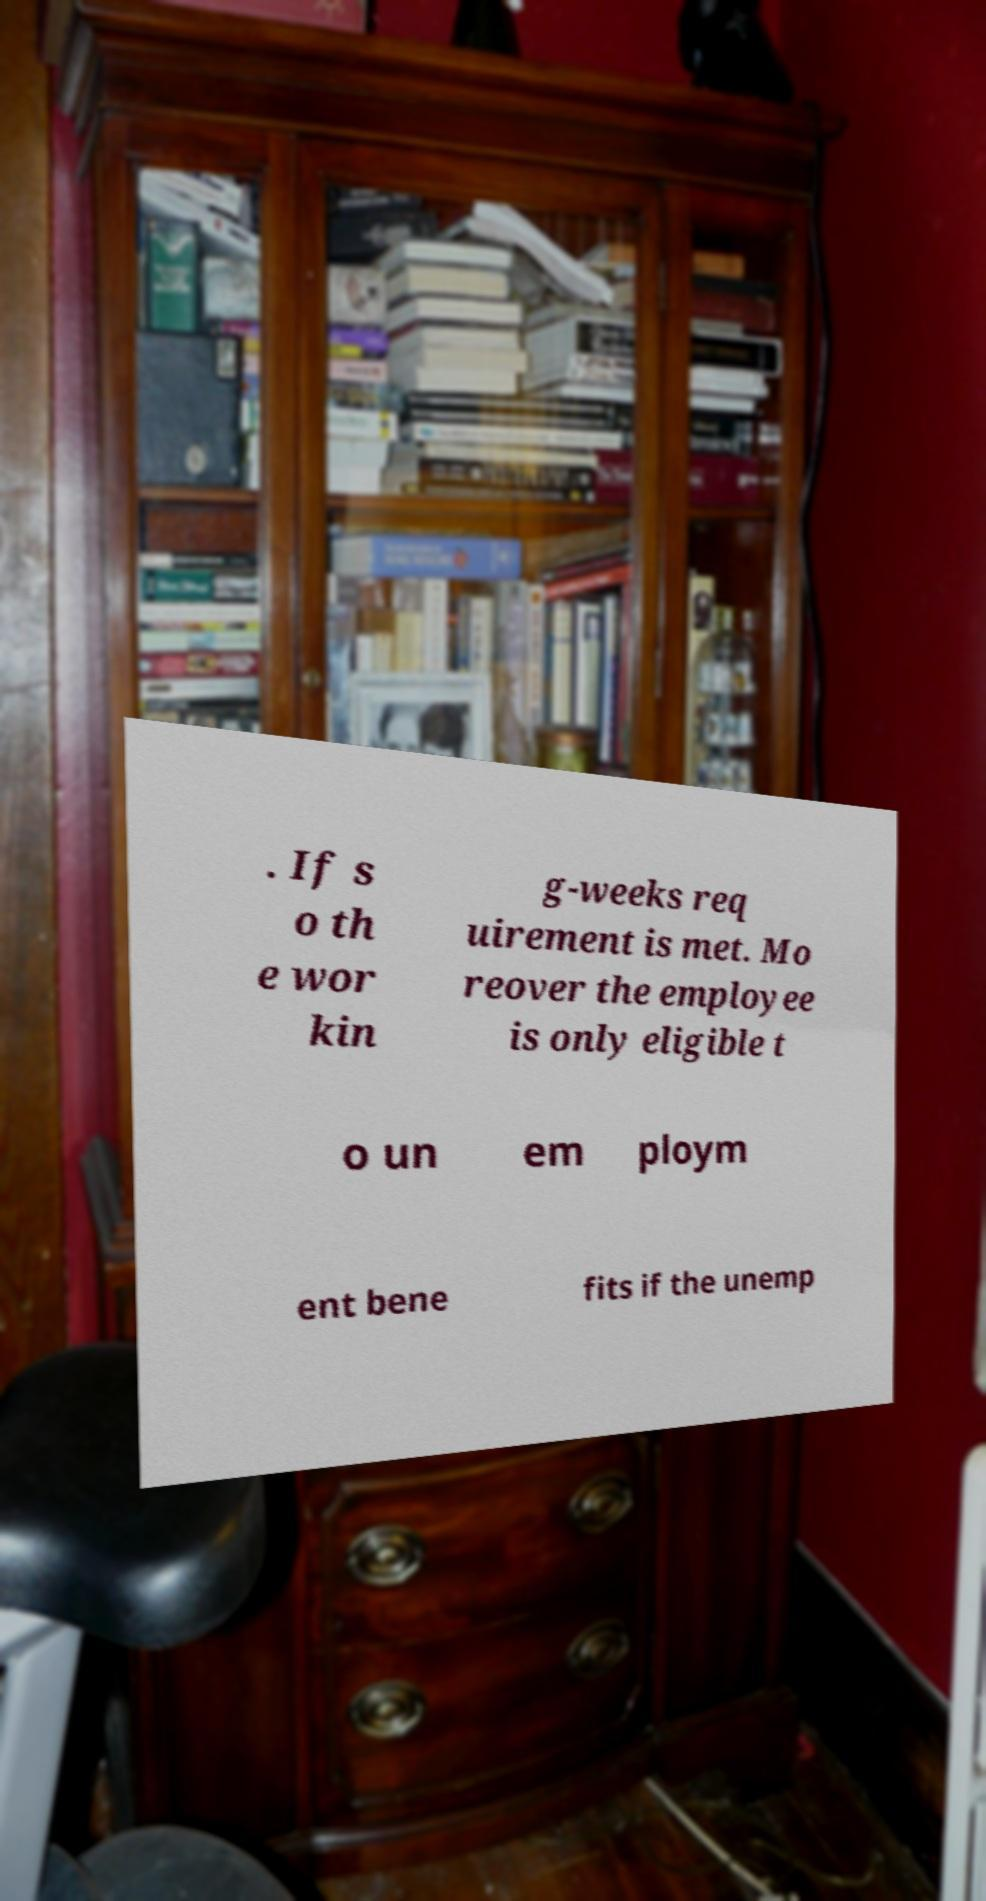Could you assist in decoding the text presented in this image and type it out clearly? . If s o th e wor kin g-weeks req uirement is met. Mo reover the employee is only eligible t o un em ploym ent bene fits if the unemp 